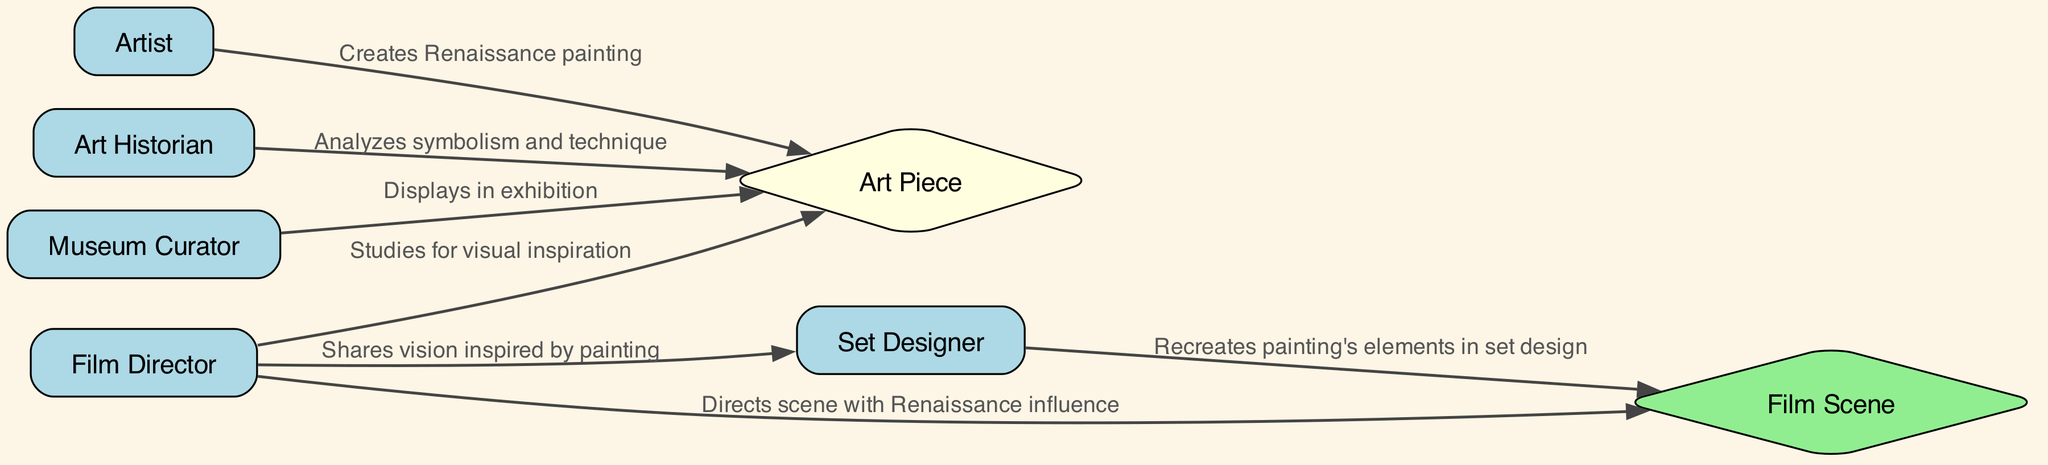What are the actors involved in the sequence? The sequence diagram includes five actors: Artist, Art Historian, Museum Curator, Film Director, and Set Designer. This can be determined by looking at the actor nodes present in the diagram.
Answer: Artist, Art Historian, Museum Curator, Film Director, Set Designer How many edges are in the diagram? The edges represent the actions between the nodes. By counting the connections (or arrows) in the sequence, we find that there are six edges linking the actors and the art piece to the film scene.
Answer: 6 Who creates the Renaissance painting? The Artist is the one who initiates the sequence by creating the Renaissance painting, as indicated by the first action from the Artist to the Art Piece.
Answer: Artist Which actor analyzes the art piece? The Art Historian is responsible for analyzing the symbolism and technique of the art piece, as shown in the second action coming from the Art Historian towards the Art Piece.
Answer: Art Historian What does the Film Director share with the Set Designer? The Film Director shares their vision inspired by the painting with the Set Designer. This is noted in the action where the Film Director connects to the Set Designer in the diagram.
Answer: Vision inspired by painting How is the painting's influence shown in the film scene? The Film Director directs the scene with a Renaissance influence, which illustrates how the art piece's elements are integrated into the filmmaking process, confirmed by the last interaction between the Film Director and the Film Scene.
Answer: Directs scene with Renaissance influence What is the final output of the sequence? The final output of the sequence is the Film Scene, which is influenced by the Renaissance painting through the collaborative efforts of the Film Director and Set Designer. This is the last node in the flow of actions depicted in the diagram.
Answer: Film Scene Which actor displays the art piece in an exhibition? The Museum Curator is the actor who displays the art piece in an exhibition, as indicated in the third action flowing from the Museum Curator to the Art Piece.
Answer: Museum Curator What action occurs between the Set Designer and the Film Scene? The Set Designer recreates the painting's elements in the set design, which is the direct action shown between the Set Designer and the Film Scene in the diagram.
Answer: Recreates painting's elements in set design 